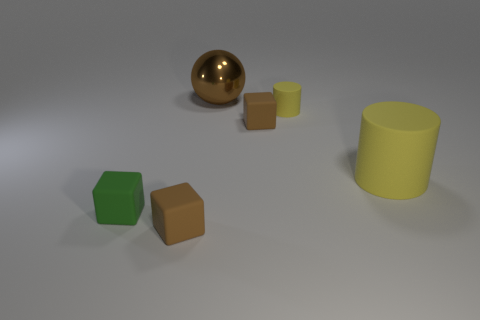Add 1 big metallic balls. How many objects exist? 7 Subtract all cylinders. How many objects are left? 4 Subtract all large spheres. Subtract all large metal objects. How many objects are left? 4 Add 3 yellow matte cylinders. How many yellow matte cylinders are left? 5 Add 4 small matte things. How many small matte things exist? 8 Subtract 0 blue cylinders. How many objects are left? 6 